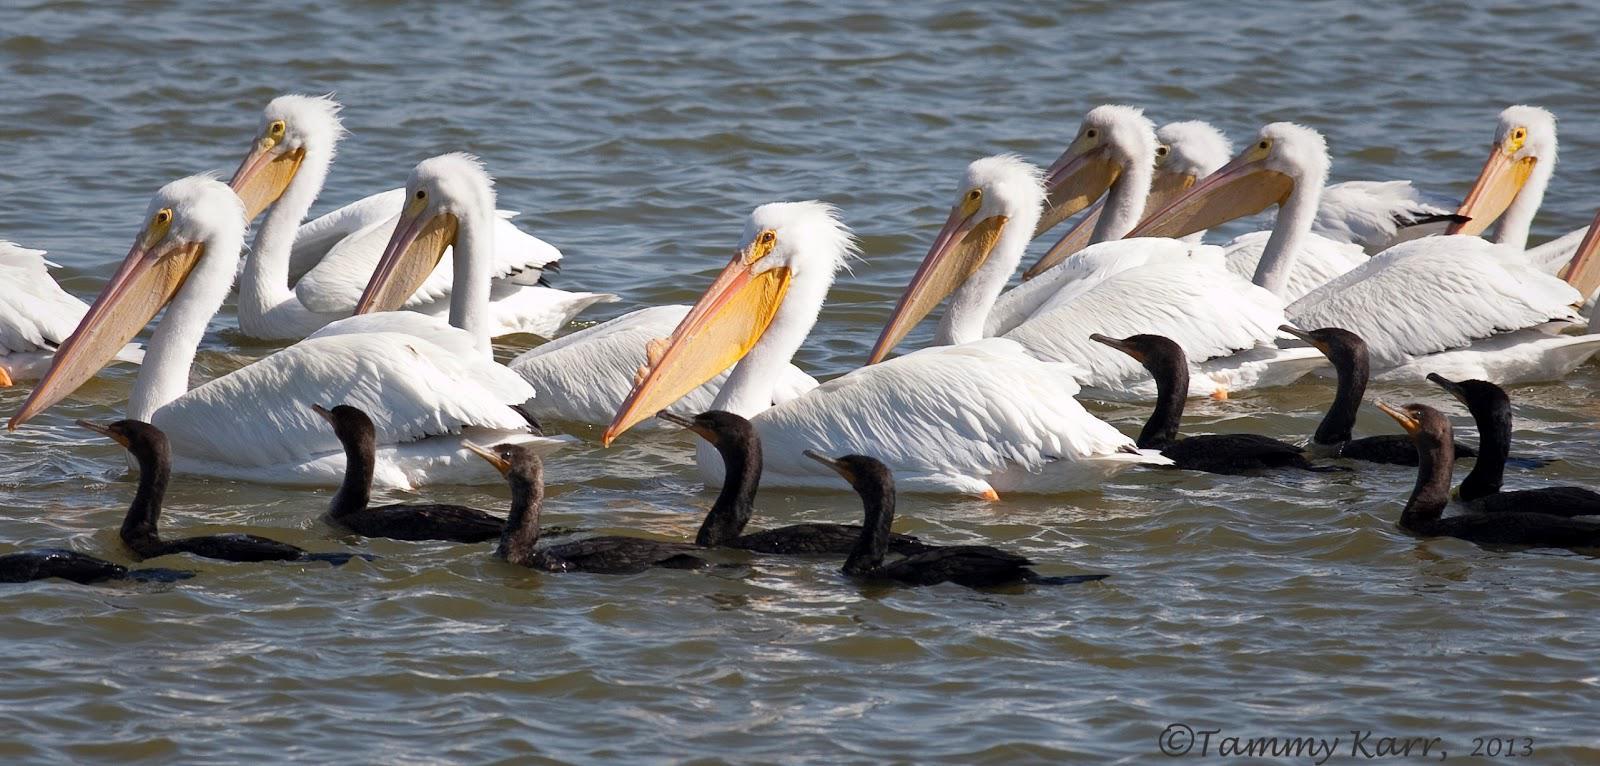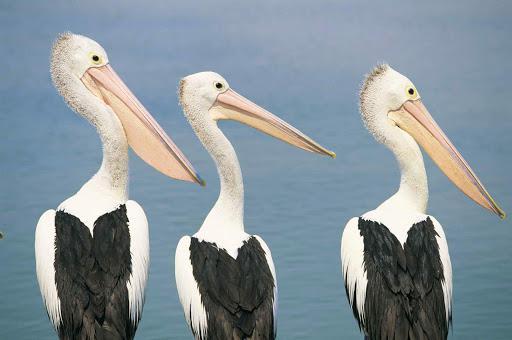The first image is the image on the left, the second image is the image on the right. Assess this claim about the two images: "In one of the image there is a pelican in the water.". Correct or not? Answer yes or no. Yes. The first image is the image on the left, the second image is the image on the right. Given the left and right images, does the statement "At least 6 pelicans face left." hold true? Answer yes or no. Yes. 